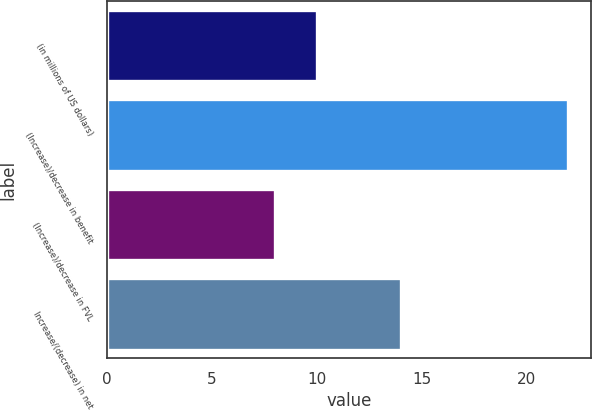Convert chart to OTSL. <chart><loc_0><loc_0><loc_500><loc_500><bar_chart><fcel>(in millions of US dollars)<fcel>(Increase)/decrease in benefit<fcel>(Increase)/decrease in FVL<fcel>Increase/(decrease) in net<nl><fcel>10<fcel>22<fcel>8<fcel>14<nl></chart> 